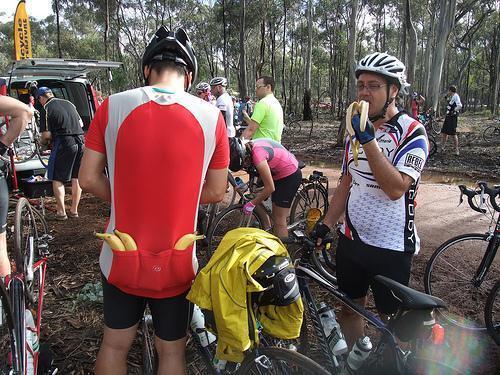How many bananas are in the red pocket?
Give a very brief answer. 3. How many bananas doe the guy have in his back pocket?
Give a very brief answer. 3. 